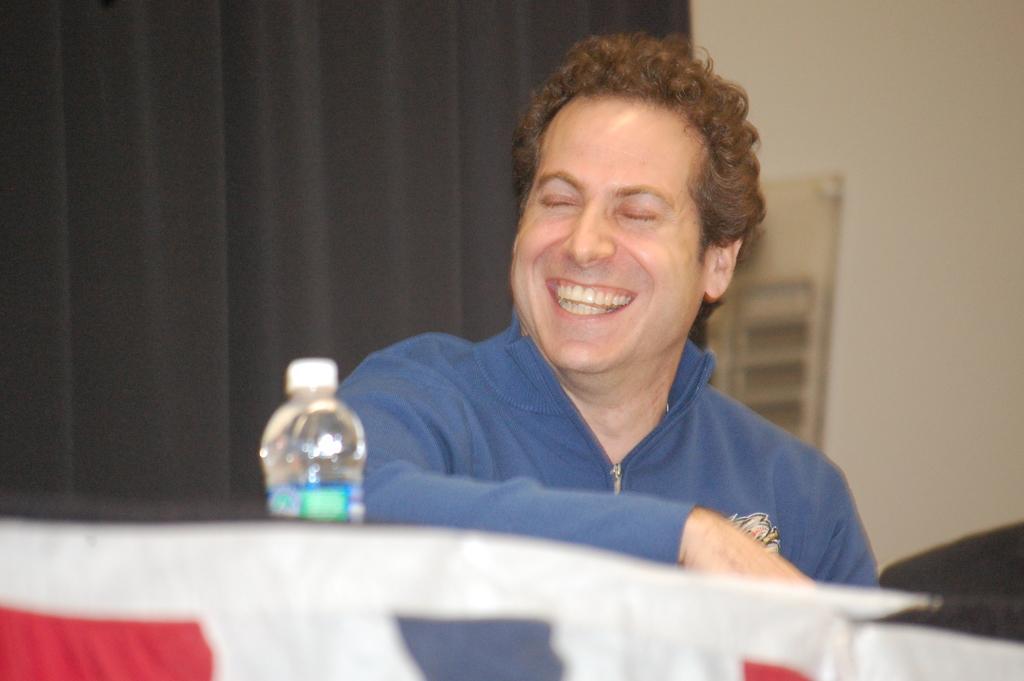How would you summarize this image in a sentence or two? In this image I can see a man and he is wearing a blue jacket, I can also see smile on his face. Here I can see a water bottle. 